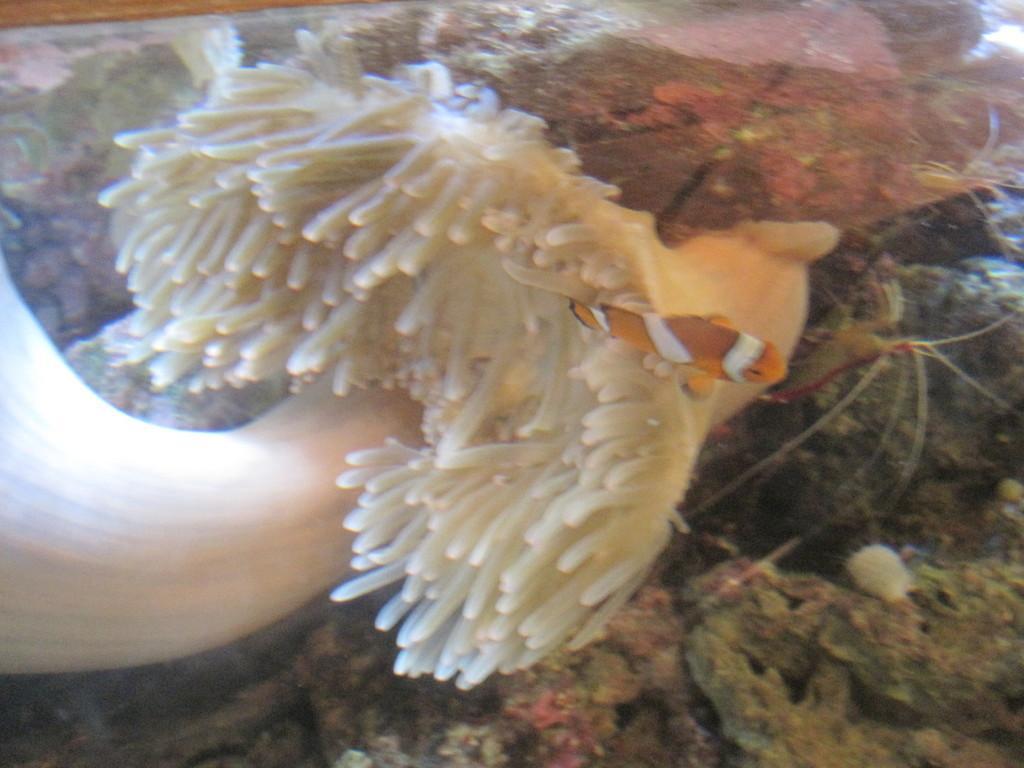Describe this image in one or two sentences. In this picture I can see a marine plant, few frocks and a fish in the water. 